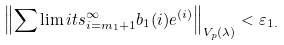<formula> <loc_0><loc_0><loc_500><loc_500>\left \| \sum \lim i t s _ { i = m _ { 1 } + 1 } ^ { \infty } b _ { 1 } ( i ) e ^ { ( i ) } \right \| _ { V _ { p } ( \lambda ) } < \varepsilon _ { 1 . }</formula> 